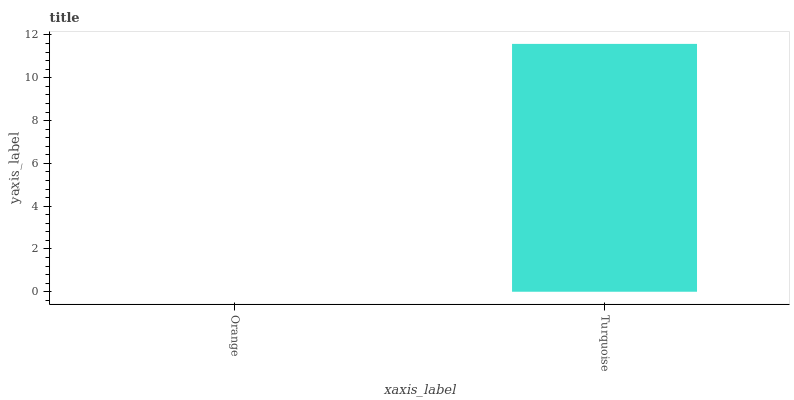Is Orange the minimum?
Answer yes or no. Yes. Is Turquoise the maximum?
Answer yes or no. Yes. Is Turquoise the minimum?
Answer yes or no. No. Is Turquoise greater than Orange?
Answer yes or no. Yes. Is Orange less than Turquoise?
Answer yes or no. Yes. Is Orange greater than Turquoise?
Answer yes or no. No. Is Turquoise less than Orange?
Answer yes or no. No. Is Turquoise the high median?
Answer yes or no. Yes. Is Orange the low median?
Answer yes or no. Yes. Is Orange the high median?
Answer yes or no. No. Is Turquoise the low median?
Answer yes or no. No. 